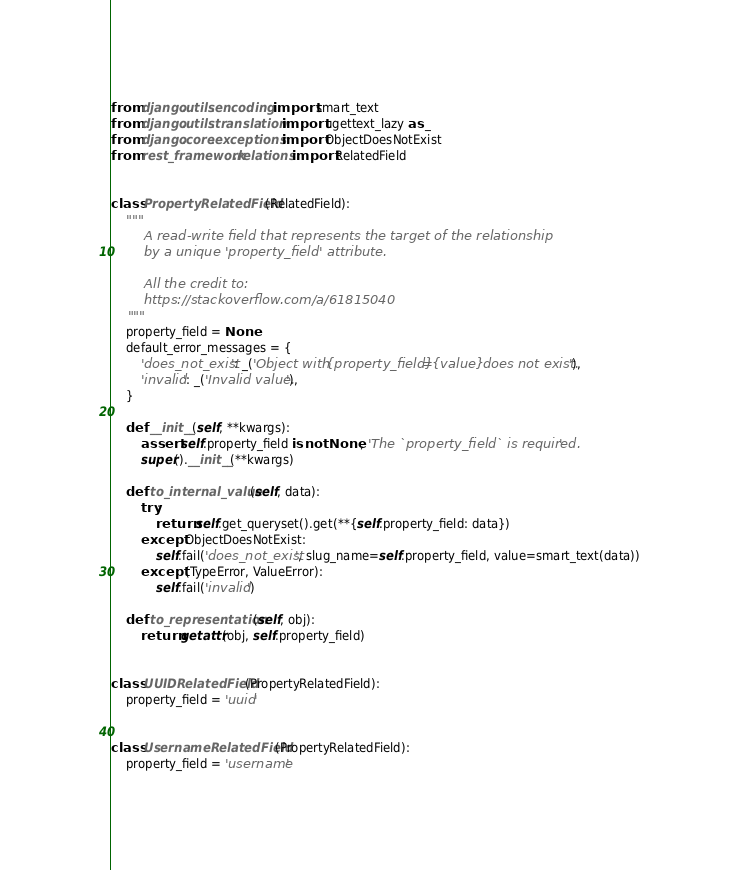<code> <loc_0><loc_0><loc_500><loc_500><_Python_>from django.utils.encoding import smart_text
from django.utils.translation import ugettext_lazy as _
from django.core.exceptions import ObjectDoesNotExist
from rest_framework.relations import RelatedField


class PropertyRelatedField(RelatedField):
    """
        A read-write field that represents the target of the relationship
        by a unique 'property_field' attribute.

        All the credit to:
        https://stackoverflow.com/a/61815040
    """
    property_field = None
    default_error_messages = {
        'does_not_exist': _('Object with {property_field}={value} does not exist.'),
        'invalid': _('Invalid value.'),
    }

    def __init__(self, **kwargs):
        assert self.property_field is not None, 'The `property_field` is required.'
        super().__init__(**kwargs)

    def to_internal_value(self, data):
        try:
            return self.get_queryset().get(**{self.property_field: data})
        except ObjectDoesNotExist:
            self.fail('does_not_exist', slug_name=self.property_field, value=smart_text(data))
        except (TypeError, ValueError):
            self.fail('invalid')

    def to_representation(self, obj):
        return getattr(obj, self.property_field)


class UUIDRelatedField(PropertyRelatedField):
    property_field = 'uuid'


class UsernameRelatedField(PropertyRelatedField):
    property_field = 'username'
</code> 